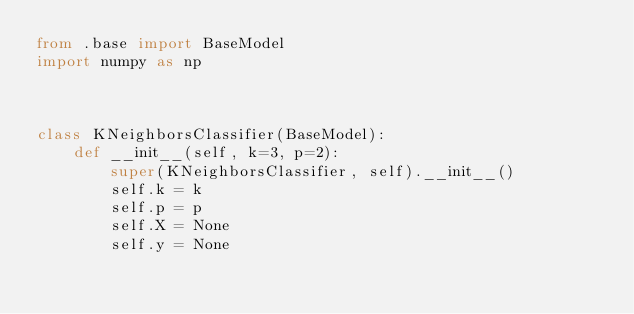<code> <loc_0><loc_0><loc_500><loc_500><_Python_>from .base import BaseModel
import numpy as np



class KNeighborsClassifier(BaseModel):
    def __init__(self, k=3, p=2):
        super(KNeighborsClassifier, self).__init__()
        self.k = k
        self.p = p
        self.X = None
        self.y = None

</code> 